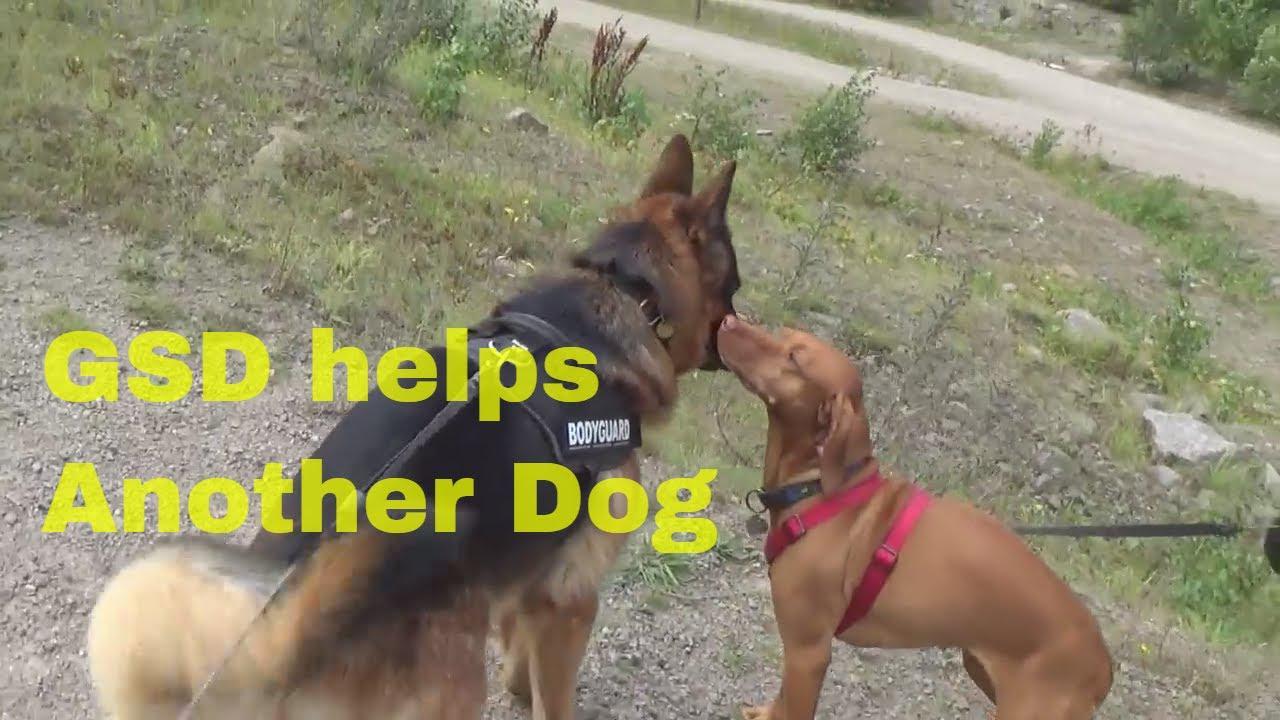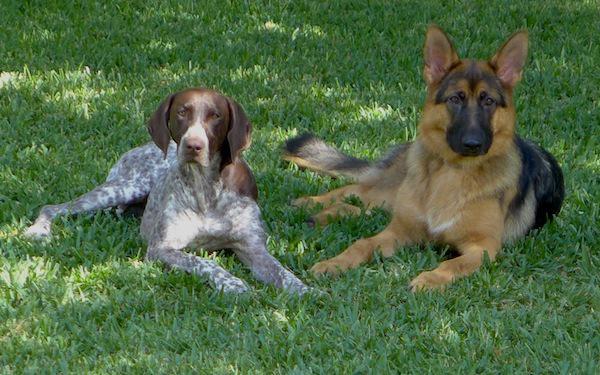The first image is the image on the left, the second image is the image on the right. For the images shown, is this caption "The combined images contain no more than three dogs, and at least two dogs are standing on all fours." true? Answer yes or no. No. The first image is the image on the left, the second image is the image on the right. Considering the images on both sides, is "The left and right image contains the same number of dogs." valid? Answer yes or no. Yes. 